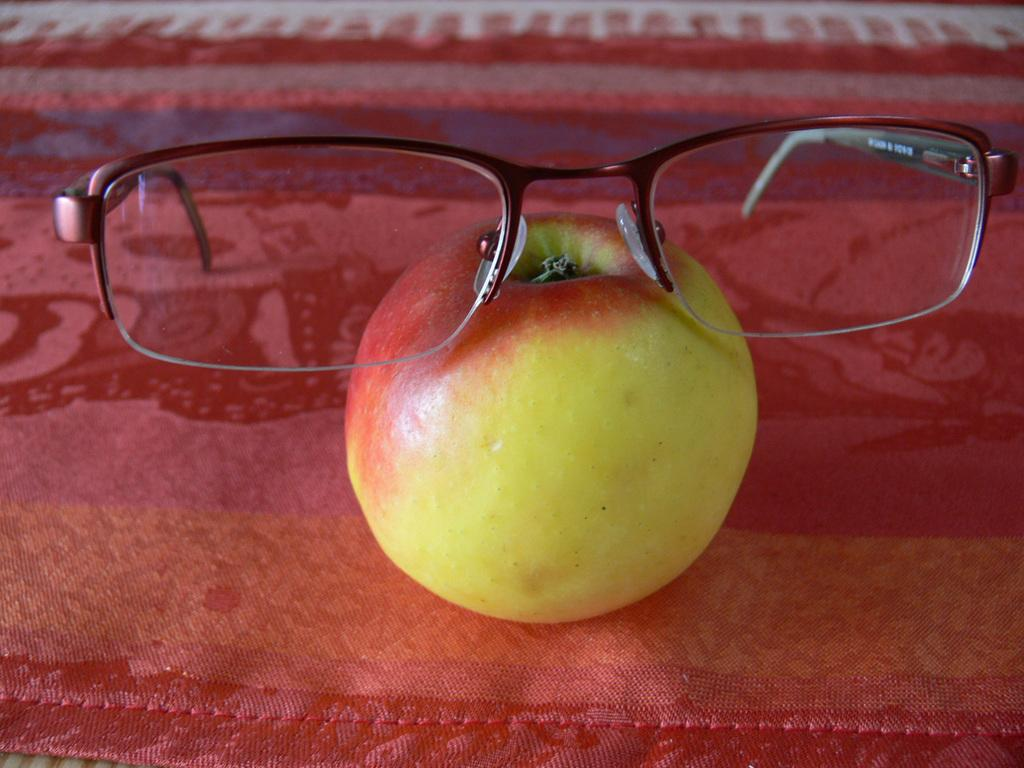What type of object is present in the image? There is a fruit in the image. What is an unusual feature of the fruit? The fruit has spectacles on it. What type of record can be seen playing in the background of the image? There is no record present in the image; it only features a fruit with spectacles. 